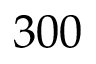<formula> <loc_0><loc_0><loc_500><loc_500>3 0 0</formula> 